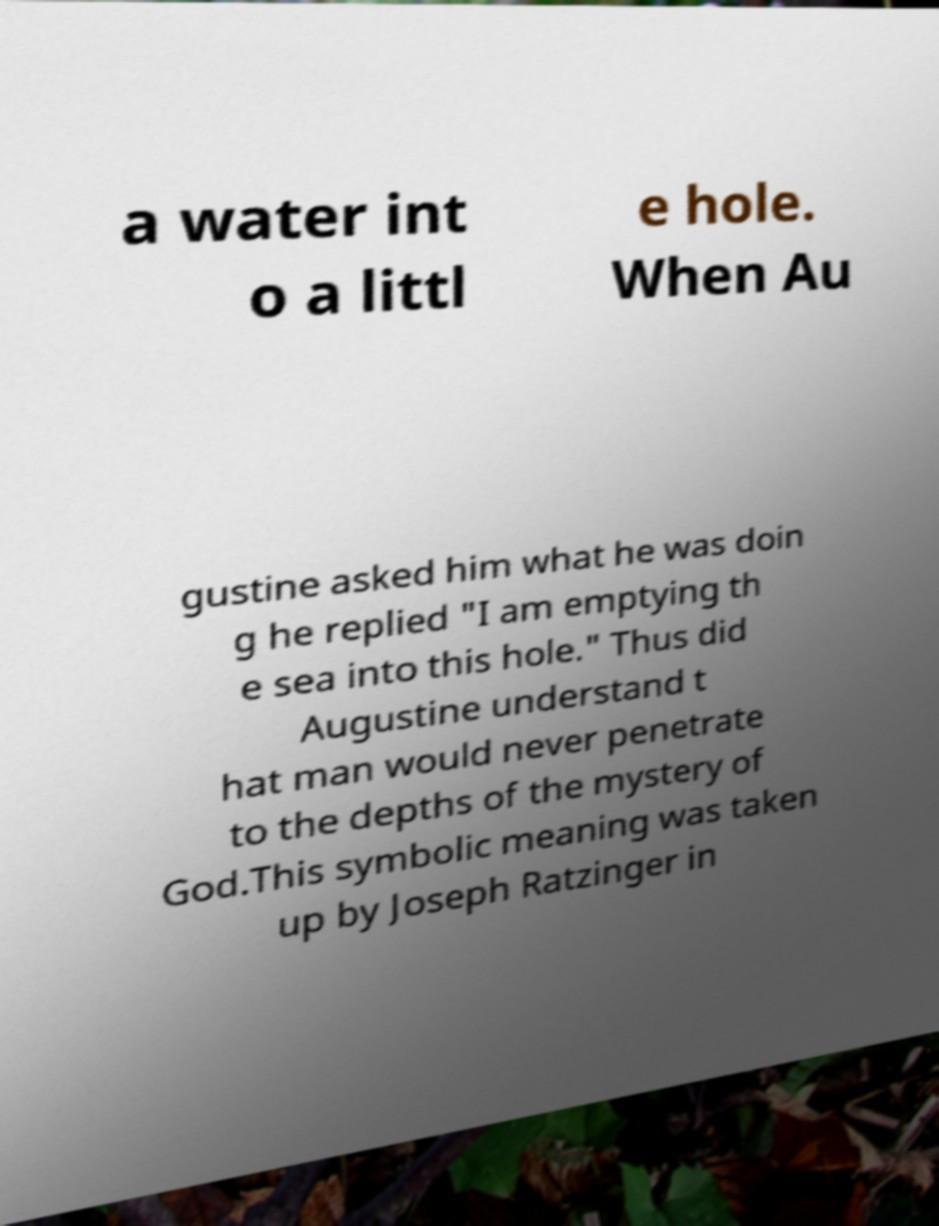Please identify and transcribe the text found in this image. a water int o a littl e hole. When Au gustine asked him what he was doin g he replied "I am emptying th e sea into this hole." Thus did Augustine understand t hat man would never penetrate to the depths of the mystery of God.This symbolic meaning was taken up by Joseph Ratzinger in 